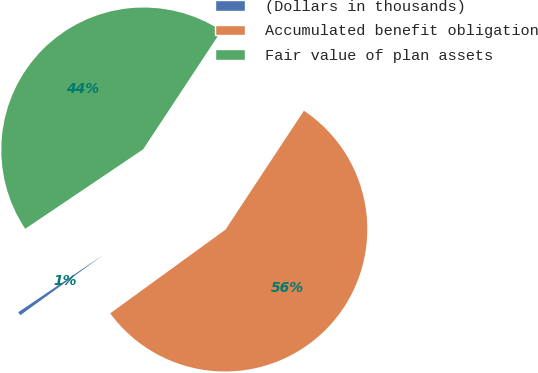Convert chart to OTSL. <chart><loc_0><loc_0><loc_500><loc_500><pie_chart><fcel>(Dollars in thousands)<fcel>Accumulated benefit obligation<fcel>Fair value of plan assets<nl><fcel>0.56%<fcel>55.72%<fcel>43.72%<nl></chart> 